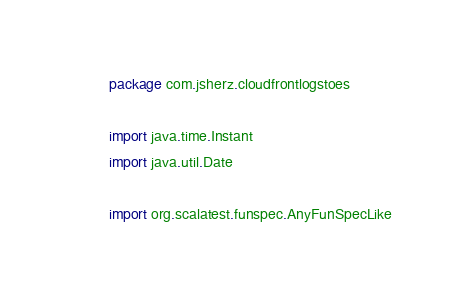<code> <loc_0><loc_0><loc_500><loc_500><_Scala_>package com.jsherz.cloudfrontlogstoes

import java.time.Instant
import java.util.Date

import org.scalatest.funspec.AnyFunSpecLike
</code> 